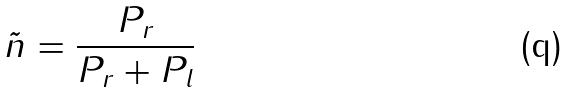<formula> <loc_0><loc_0><loc_500><loc_500>\tilde { n } = \frac { P _ { r } } { P _ { r } + P _ { l } }</formula> 